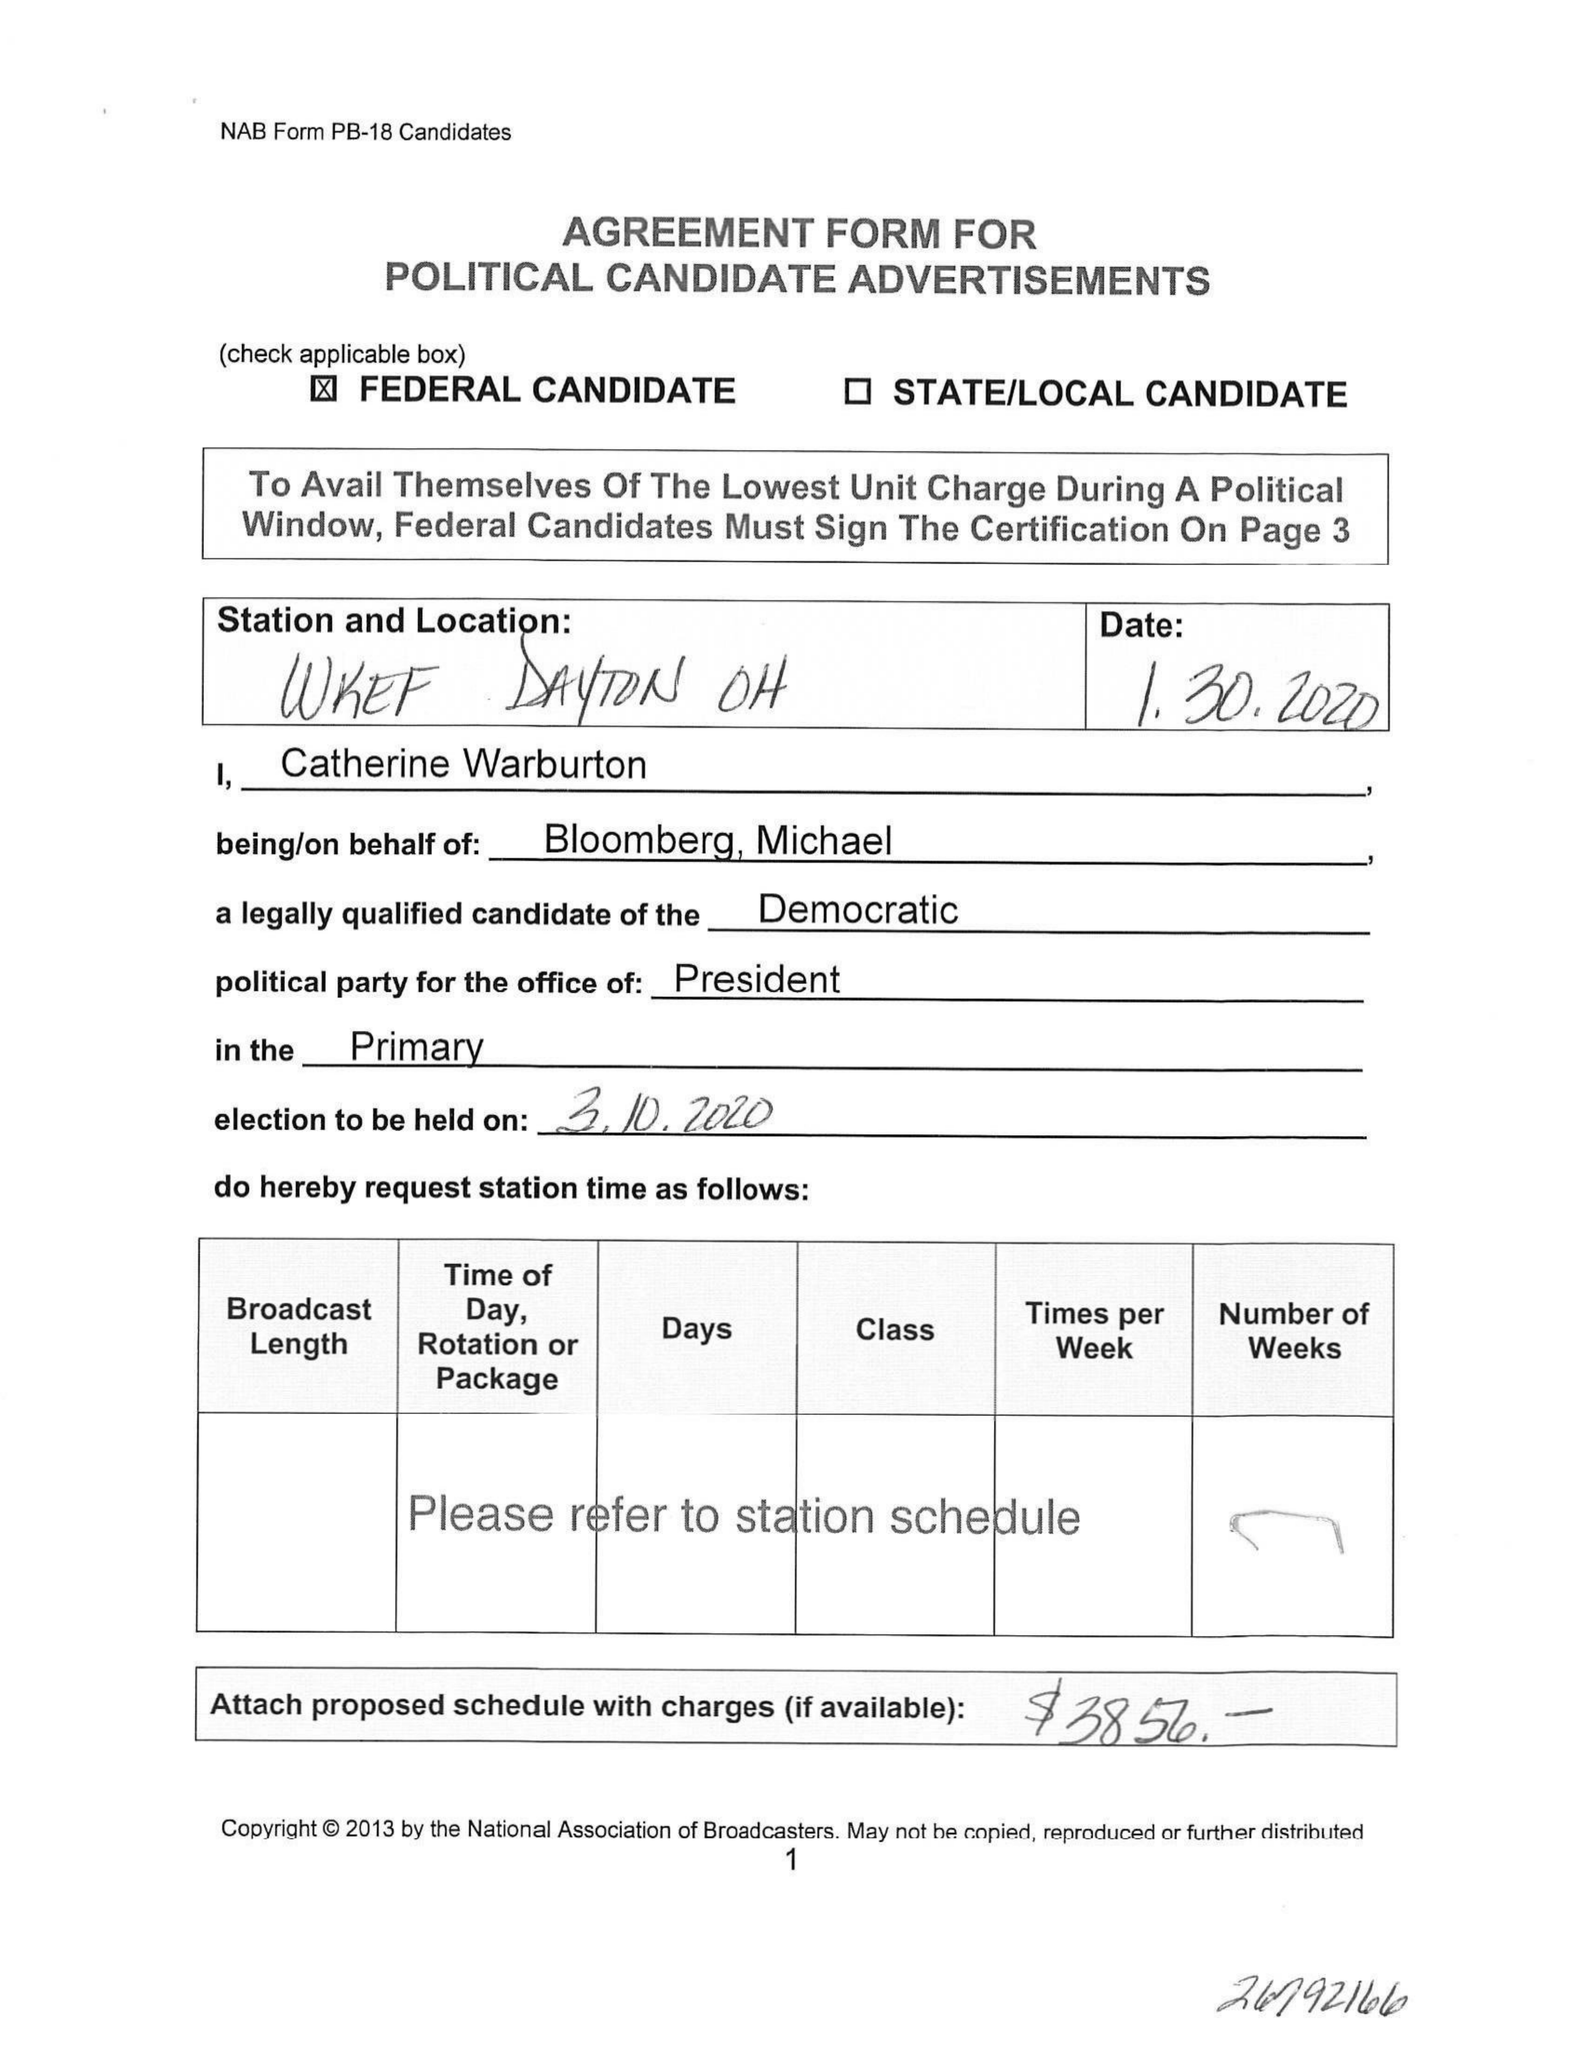What is the value for the gross_amount?
Answer the question using a single word or phrase. None 